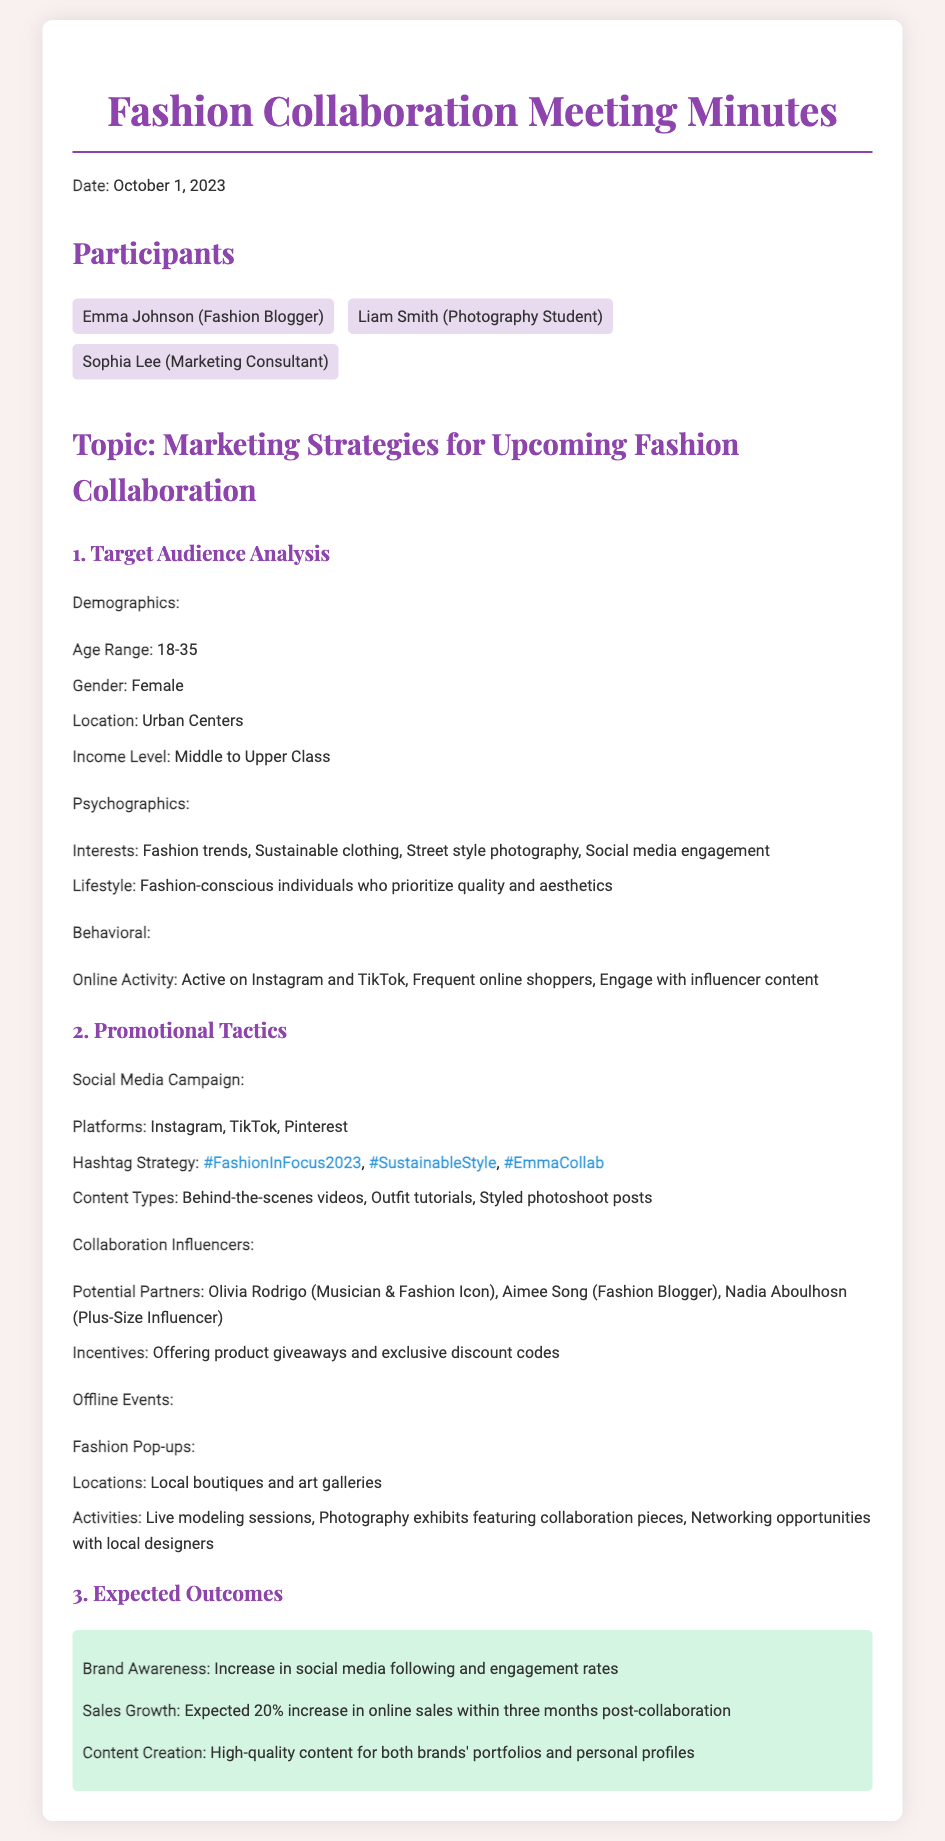what is the date of the meeting? The date of the meeting is listed at the top of the document.
Answer: October 1, 2023 who is the fashion blogger participating in the meeting? The fashion blogger's name is mentioned among the participants.
Answer: Emma Johnson what age range is defined for the target audience? The age range is specified in the demographics section of the document.
Answer: 18-35 which platforms are included in the social media campaign? The social media platforms are listed under the promotional tactics section.
Answer: Instagram, TikTok, Pinterest what is the expected increase in online sales after the collaboration? The expected sales growth is mentioned in the expected outcomes section.
Answer: 20% who is one of the potential collaboration influencers listed? The potential partners are provided in the collaboration influencers section.
Answer: Olivia Rodrigo what is one type of content mentioned for the social media campaign? The document lists various content types under the social media campaign.
Answer: Behind-the-scenes videos what activity is proposed for the offline events? Activities planned for offline events are detailed in that section of the document.
Answer: Live modeling sessions 